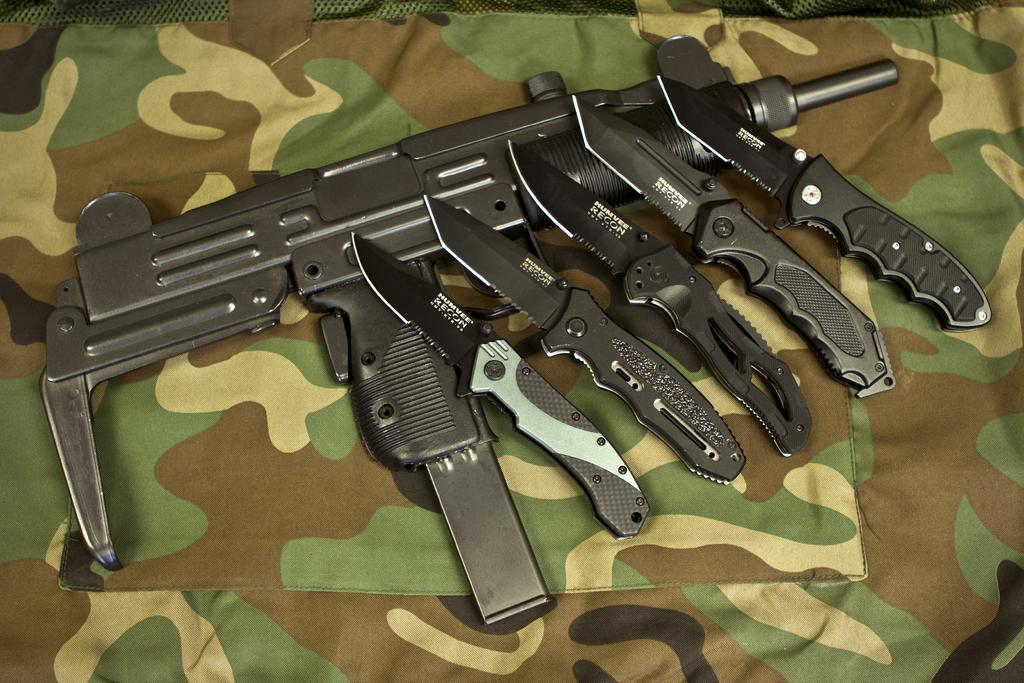What type of weapon is present in the image? There is a shooting gun in the image. What other sharp objects can be seen in the image? There are knives in the image. How are the knives and shooting gun arranged in the image? The knives and shooting gun are placed on a cloth. What type of account is being discussed in the image? There is no account being discussed in the image; it features a shooting gun and knives placed on a cloth. Can you describe the person holding the shooting gun in the image? There is no person present in the image; it only shows a shooting gun and knives placed on a cloth. 